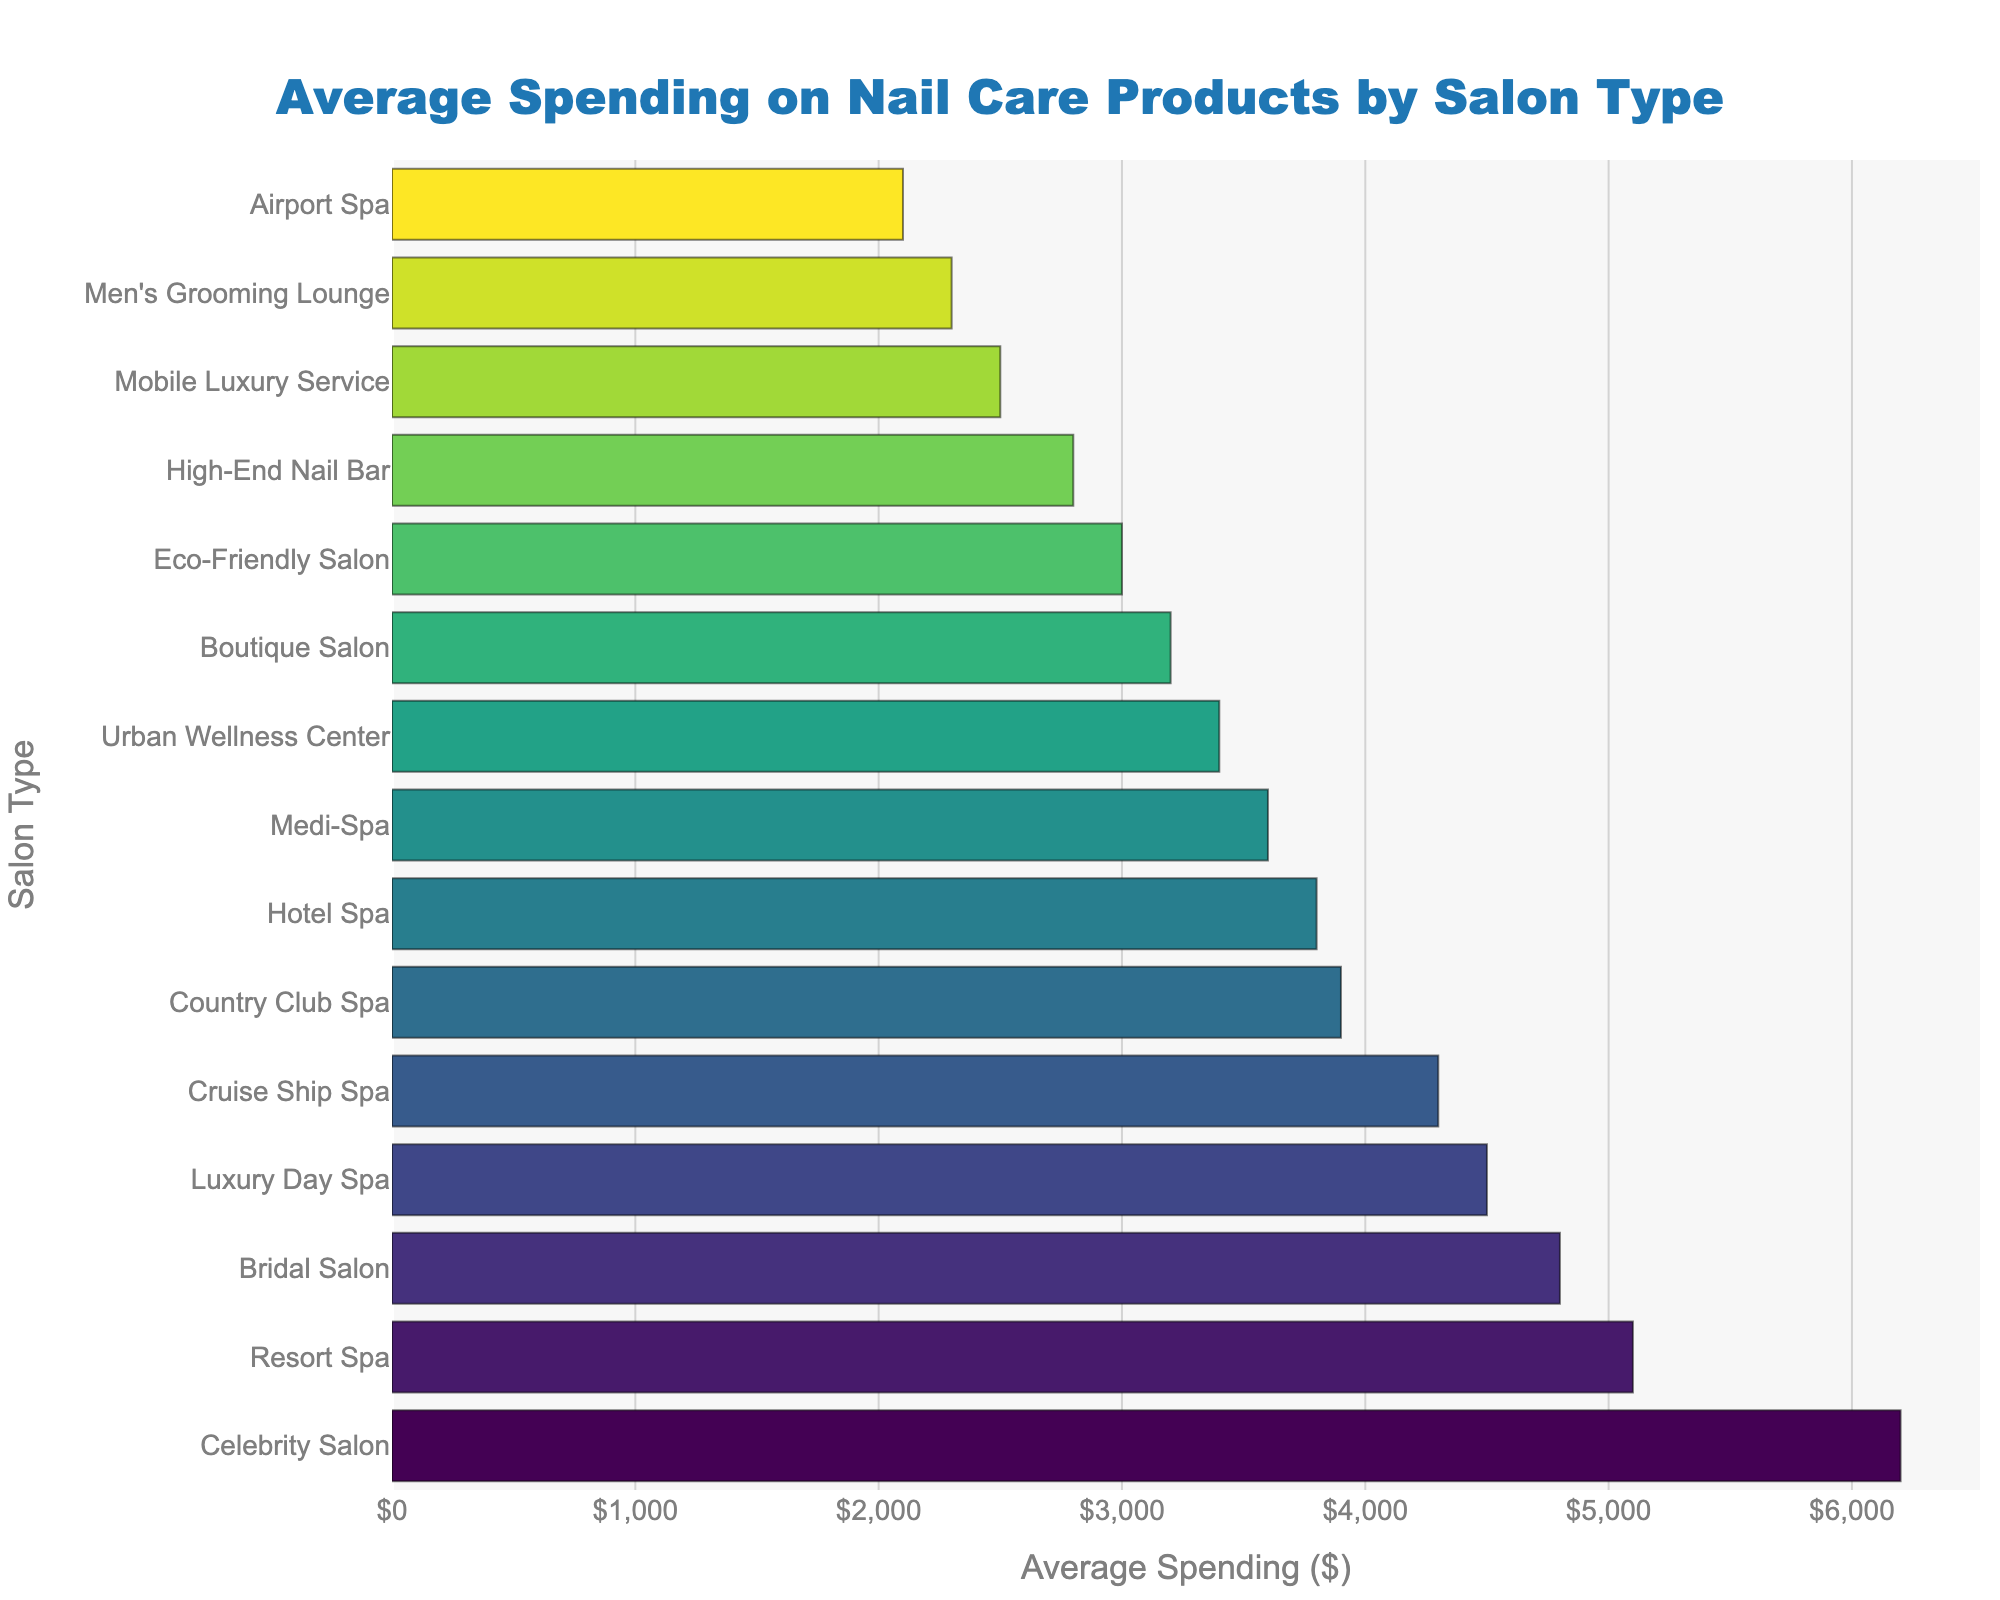Which salon type has the highest average spending on nail care products? The Celebrity Salon has the bar with the greatest length, indicating it has the highest average spending.
Answer: Celebrity Salon Which salon types have an average spending below $3,000? Identify the bars that are shorter than the $3,000 mark. They are the Eco-Friendly Salon, Mobile Luxury Service, Airport Spa, and Men's Grooming Lounge.
Answer: Eco-Friendly Salon, Mobile Luxury Service, Airport Spa, Men's Grooming Lounge What is the difference in average spending between the Boutique Salon and Hotel Spa? The Boutique Salon has an average spending of $3,200 and the Hotel Spa has $3,800. Calculate the difference: $3,800 - $3,200.
Answer: $600 Which salon type spends more on average: the Resort Spa or the Cruise Ship Spa? Compare the lengths of the bars for Resort Spa ($5,100) and Cruise Ship Spa ($4,300). Resort Spa's bar is longer, indicating higher spending.
Answer: Resort Spa By how much does the Luxury Day Spa outspend the Boutique Salon on average? The Luxury Day Spa has an average spending of $4,500 while the Boutique Salon spends $3,200. Subtract to find the difference: $4,500 - $3,200.
Answer: $1,300 What is the combined average spending of the Celebrity Salon and the Bridal Salon? Add the average spendings of the Celebrity Salon ($6,200) and the Bridal Salon ($4,800): $6,200 + $4,800.
Answer: $11,000 Which salon type has the lowest average spending on nail care products? The Men's Grooming Lounge has the shortest bar, indicating the lowest spending of $2,300.
Answer: Men's Grooming Lounge How much more, on average, does the Country Club Spa spend compared to the High-End Nail Bar? The Country Club Spa spends $3,900 and the High-End Nail Bar spends $2,800. Calculate: $3,900 - $2,800.
Answer: $1,100 Is there any salon type with spending exactly $3,600? Yes, the Medi-Spa has an average spending exactly at $3,600.
Answer: Medi-Spa What's the average spending difference between an Eco-Friendly Salon and Urban Wellness Center? The Eco-Friendly Salon spends $3,000 and Urban Wellness Center spends $3,400. The difference is: $3,400 - $3,000.
Answer: $400 